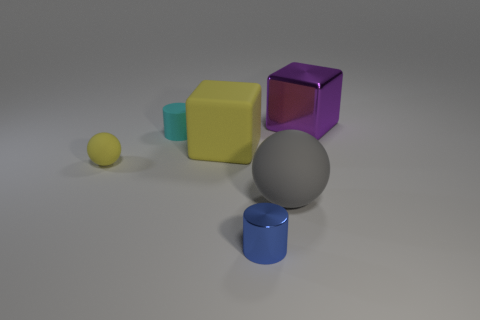How many things are either cubes that are on the right side of the blue thing or small cylinders?
Make the answer very short. 3. There is a sphere that is to the right of the large block left of the object behind the small cyan cylinder; what is its size?
Your response must be concise. Large. There is a large thing that is the same color as the small rubber sphere; what is its material?
Give a very brief answer. Rubber. Is there anything else that is the same shape as the large gray object?
Ensure brevity in your answer.  Yes. What is the size of the cylinder that is in front of the rubber ball that is left of the gray sphere?
Your answer should be compact. Small. How many large things are brown rubber things or matte balls?
Offer a terse response. 1. Are there fewer purple shiny cubes than big matte objects?
Ensure brevity in your answer.  Yes. Do the small sphere and the big matte cube have the same color?
Provide a short and direct response. Yes. Are there more tiny shiny things than rubber things?
Give a very brief answer. No. How many other objects are the same color as the large sphere?
Your answer should be compact. 0. 